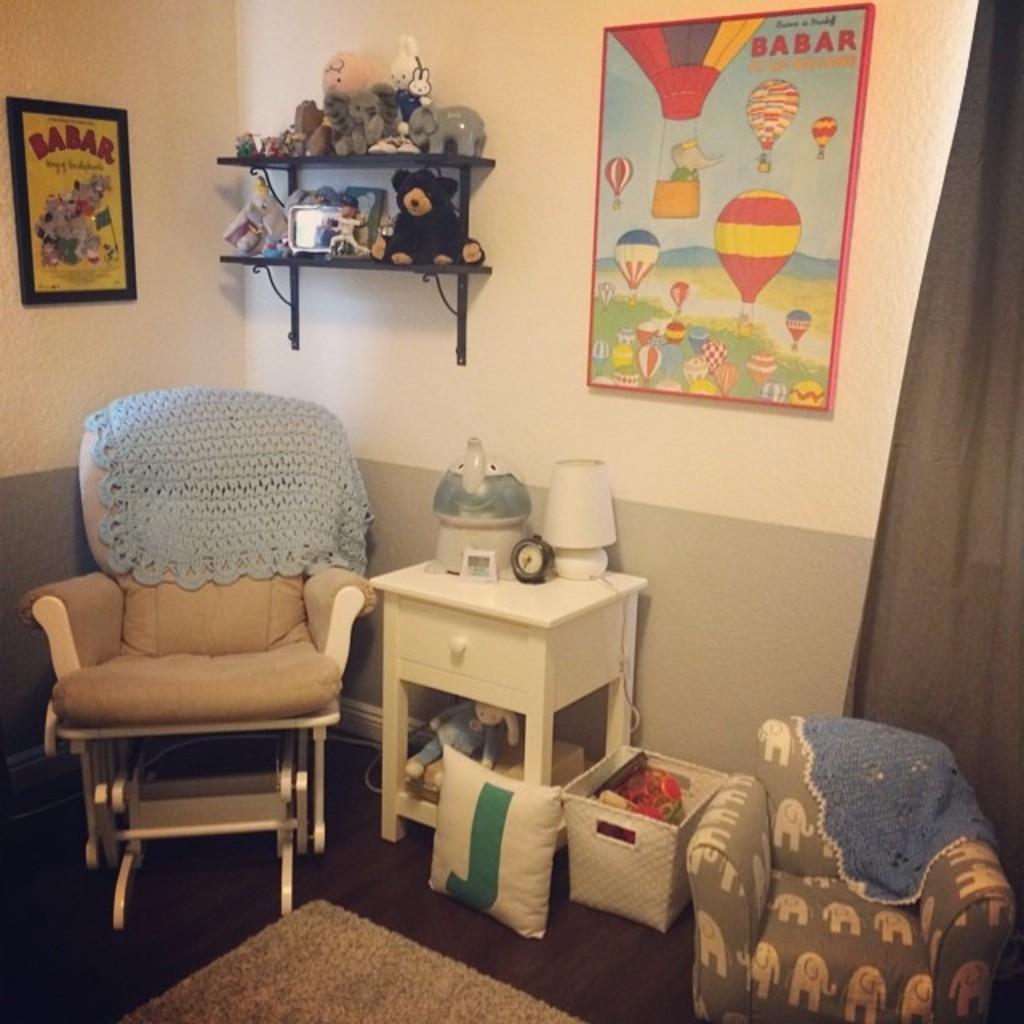Can you describe this image briefly? In this image, we can see a chair with cloth, white table. Few objects are placed on it. Here we can see cushion, basket, few objects. Here we can see a small chair with cloth. At the bottom, we can see a floor with floor mat. Background there is a wall, shelves, few toys, boards. 